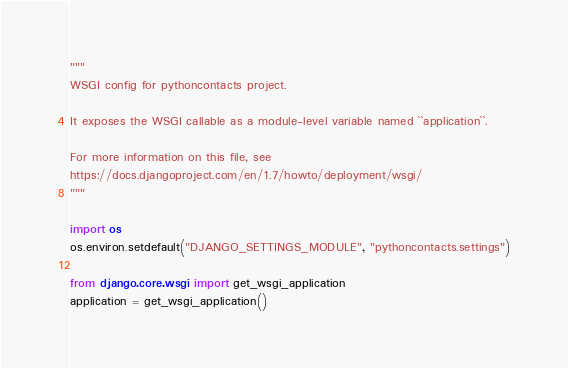Convert code to text. <code><loc_0><loc_0><loc_500><loc_500><_Python_>"""
WSGI config for pythoncontacts project.

It exposes the WSGI callable as a module-level variable named ``application``.

For more information on this file, see
https://docs.djangoproject.com/en/1.7/howto/deployment/wsgi/
"""

import os
os.environ.setdefault("DJANGO_SETTINGS_MODULE", "pythoncontacts.settings")

from django.core.wsgi import get_wsgi_application
application = get_wsgi_application()
</code> 